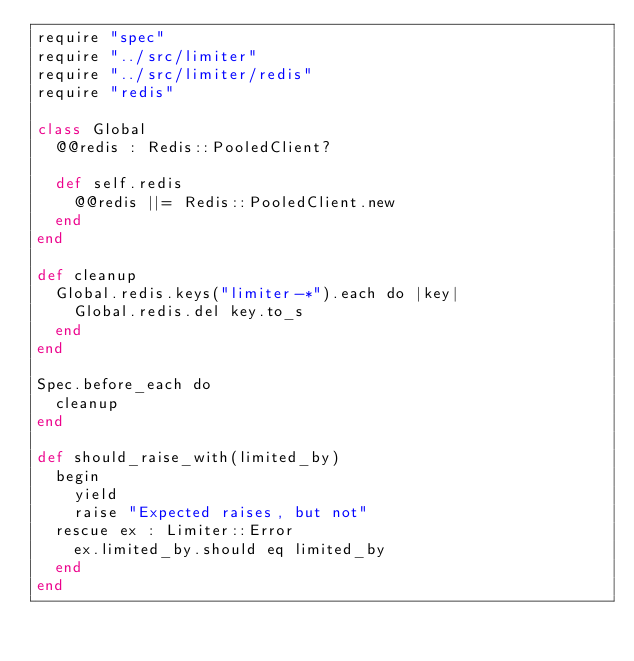<code> <loc_0><loc_0><loc_500><loc_500><_Crystal_>require "spec"
require "../src/limiter"
require "../src/limiter/redis"
require "redis"

class Global
  @@redis : Redis::PooledClient?

  def self.redis
    @@redis ||= Redis::PooledClient.new
  end
end

def cleanup
  Global.redis.keys("limiter-*").each do |key|
    Global.redis.del key.to_s
  end
end

Spec.before_each do
  cleanup
end

def should_raise_with(limited_by)
  begin
    yield
    raise "Expected raises, but not"
  rescue ex : Limiter::Error
    ex.limited_by.should eq limited_by
  end
end
</code> 